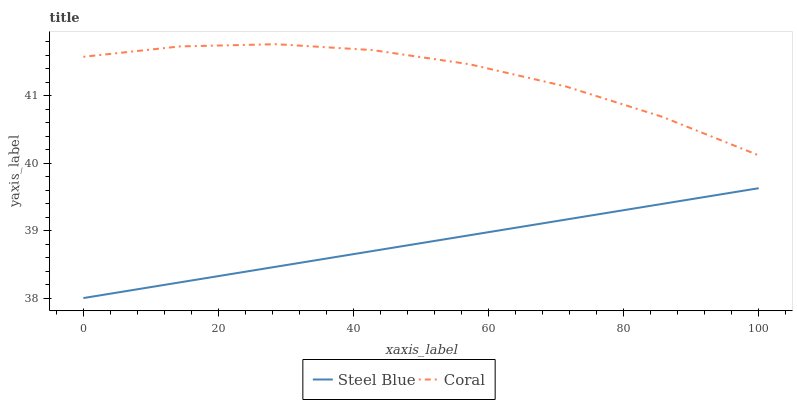Does Steel Blue have the maximum area under the curve?
Answer yes or no. No. Is Steel Blue the roughest?
Answer yes or no. No. Does Steel Blue have the highest value?
Answer yes or no. No. Is Steel Blue less than Coral?
Answer yes or no. Yes. Is Coral greater than Steel Blue?
Answer yes or no. Yes. Does Steel Blue intersect Coral?
Answer yes or no. No. 